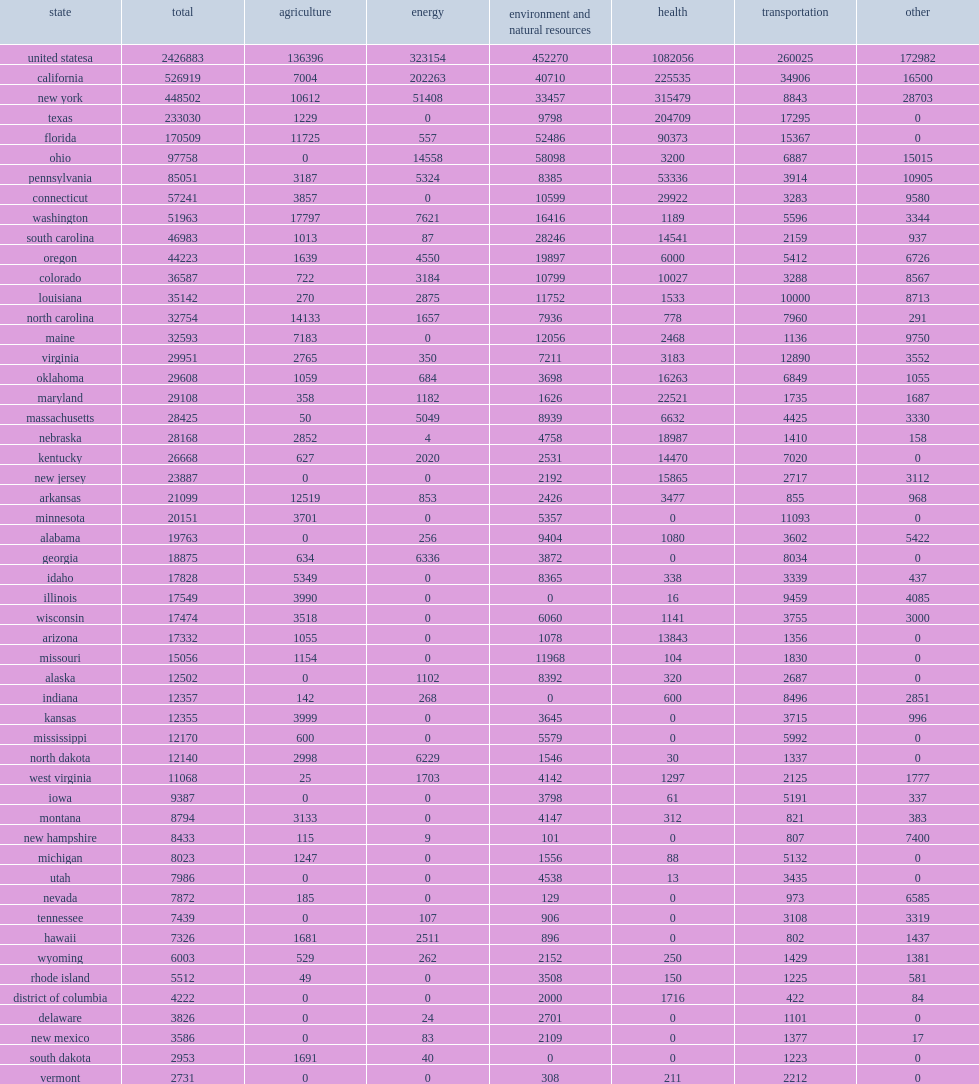Although health-related r&d declined nearly 2% from fy 2018, how many thousand dollars of expenditures for state r&d which remains the largest function in fy 2019? 1082056.0. 